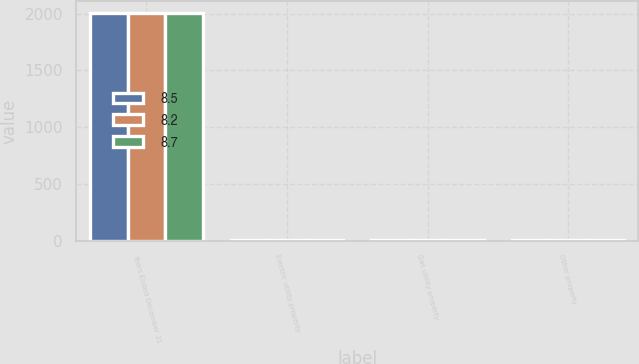Convert chart to OTSL. <chart><loc_0><loc_0><loc_500><loc_500><stacked_bar_chart><ecel><fcel>Years Ended December 31<fcel>Electric utility property<fcel>Gas utility property<fcel>Other property<nl><fcel>8.5<fcel>2008<fcel>3<fcel>3.6<fcel>8.5<nl><fcel>8.2<fcel>2007<fcel>3<fcel>3.6<fcel>8.7<nl><fcel>8.7<fcel>2006<fcel>3.1<fcel>3.6<fcel>8.2<nl></chart> 